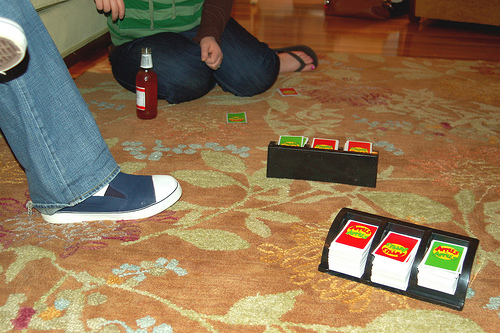<image>
Is the lady on the couch? No. The lady is not positioned on the couch. They may be near each other, but the lady is not supported by or resting on top of the couch. Is there a red cards to the right of the green cards? No. The red cards is not to the right of the green cards. The horizontal positioning shows a different relationship. 